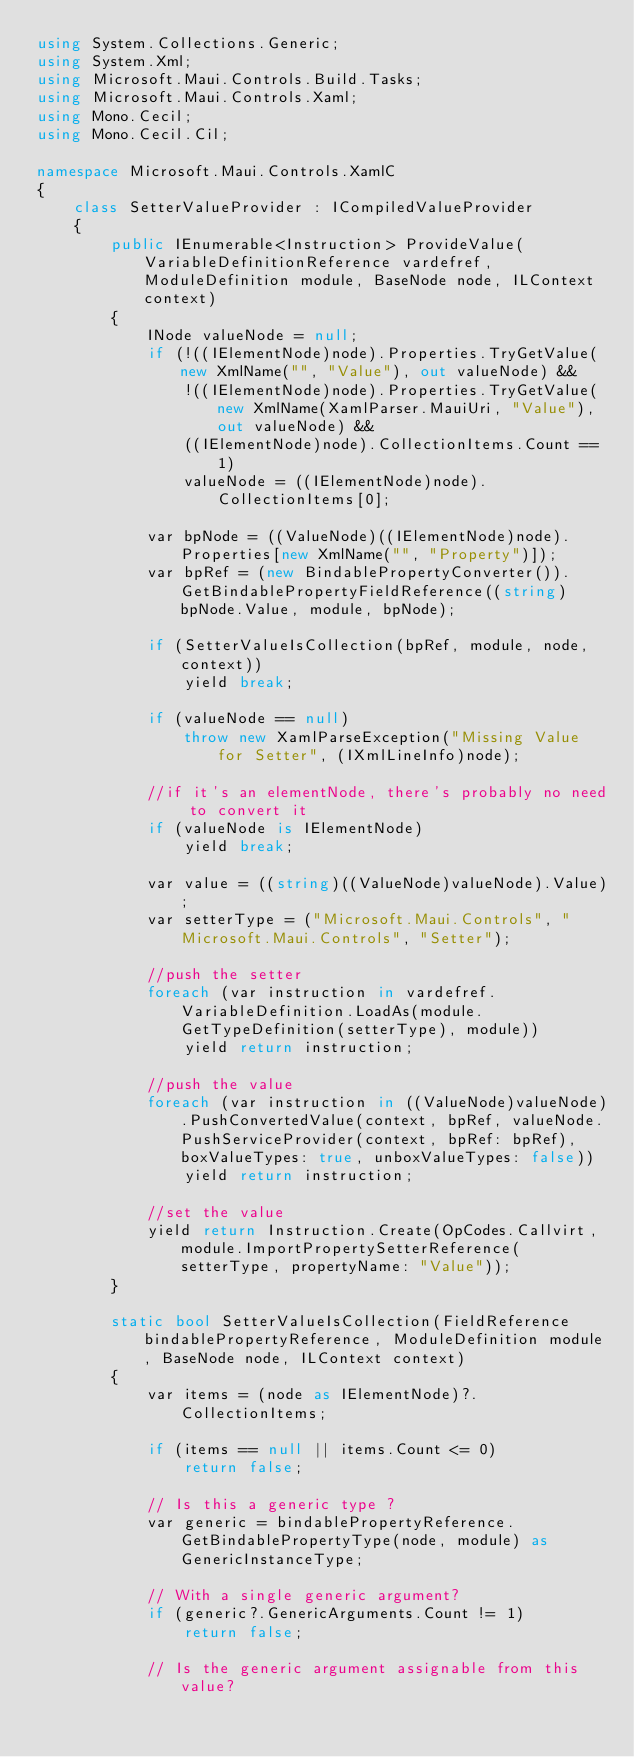<code> <loc_0><loc_0><loc_500><loc_500><_C#_>using System.Collections.Generic;
using System.Xml;
using Microsoft.Maui.Controls.Build.Tasks;
using Microsoft.Maui.Controls.Xaml;
using Mono.Cecil;
using Mono.Cecil.Cil;

namespace Microsoft.Maui.Controls.XamlC
{
	class SetterValueProvider : ICompiledValueProvider
	{
		public IEnumerable<Instruction> ProvideValue(VariableDefinitionReference vardefref, ModuleDefinition module, BaseNode node, ILContext context)
		{
			INode valueNode = null;
			if (!((IElementNode)node).Properties.TryGetValue(new XmlName("", "Value"), out valueNode) &&
				!((IElementNode)node).Properties.TryGetValue(new XmlName(XamlParser.MauiUri, "Value"), out valueNode) &&
				((IElementNode)node).CollectionItems.Count == 1)
				valueNode = ((IElementNode)node).CollectionItems[0];

			var bpNode = ((ValueNode)((IElementNode)node).Properties[new XmlName("", "Property")]);
			var bpRef = (new BindablePropertyConverter()).GetBindablePropertyFieldReference((string)bpNode.Value, module, bpNode);

			if (SetterValueIsCollection(bpRef, module, node, context))
				yield break;

			if (valueNode == null)
				throw new XamlParseException("Missing Value for Setter", (IXmlLineInfo)node);

			//if it's an elementNode, there's probably no need to convert it
			if (valueNode is IElementNode)
				yield break;

			var value = ((string)((ValueNode)valueNode).Value);
			var setterType = ("Microsoft.Maui.Controls", "Microsoft.Maui.Controls", "Setter");

			//push the setter
			foreach (var instruction in vardefref.VariableDefinition.LoadAs(module.GetTypeDefinition(setterType), module))
				yield return instruction;

			//push the value
			foreach (var instruction in ((ValueNode)valueNode).PushConvertedValue(context, bpRef, valueNode.PushServiceProvider(context, bpRef: bpRef), boxValueTypes: true, unboxValueTypes: false))
				yield return instruction;

			//set the value
			yield return Instruction.Create(OpCodes.Callvirt, module.ImportPropertySetterReference(setterType, propertyName: "Value"));
		}

		static bool SetterValueIsCollection(FieldReference bindablePropertyReference, ModuleDefinition module, BaseNode node, ILContext context)
		{
			var items = (node as IElementNode)?.CollectionItems;

			if (items == null || items.Count <= 0)
				return false;

			// Is this a generic type ?
			var generic = bindablePropertyReference.GetBindablePropertyType(node, module) as GenericInstanceType;

			// With a single generic argument?
			if (generic?.GenericArguments.Count != 1)
				return false;

			// Is the generic argument assignable from this value?</code> 